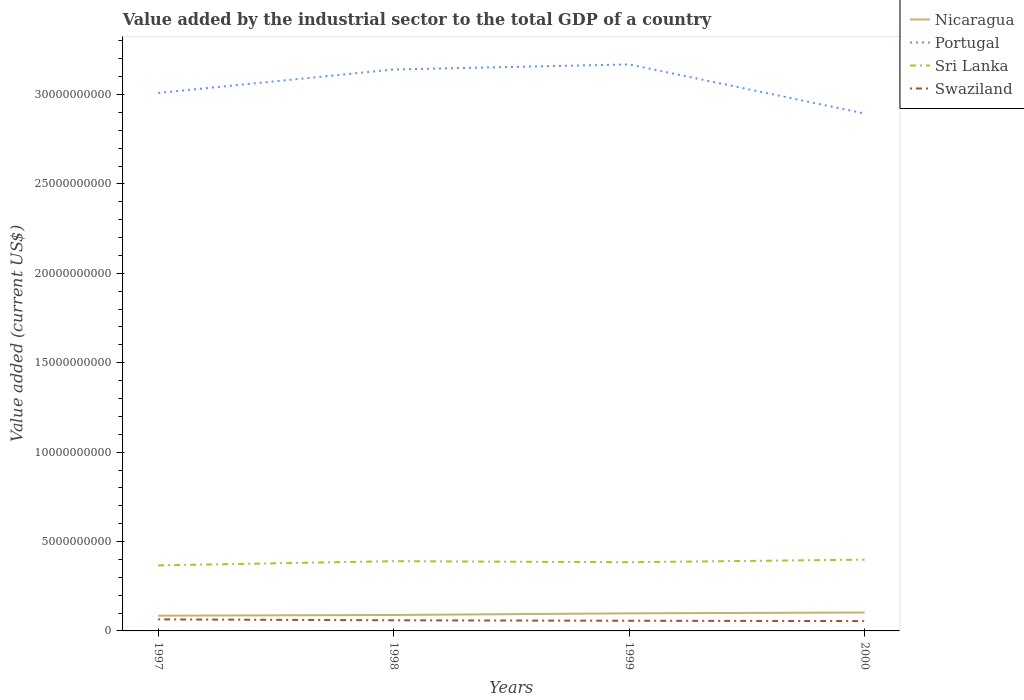How many different coloured lines are there?
Give a very brief answer. 4. Across all years, what is the maximum value added by the industrial sector to the total GDP in Nicaragua?
Offer a very short reply. 8.53e+08. In which year was the value added by the industrial sector to the total GDP in Swaziland maximum?
Keep it short and to the point. 2000. What is the total value added by the industrial sector to the total GDP in Portugal in the graph?
Offer a very short reply. -1.31e+09. What is the difference between the highest and the second highest value added by the industrial sector to the total GDP in Sri Lanka?
Offer a very short reply. 3.22e+08. What is the difference between the highest and the lowest value added by the industrial sector to the total GDP in Portugal?
Ensure brevity in your answer.  2. Does the graph contain grids?
Keep it short and to the point. No. Where does the legend appear in the graph?
Offer a very short reply. Top right. What is the title of the graph?
Keep it short and to the point. Value added by the industrial sector to the total GDP of a country. Does "Bhutan" appear as one of the legend labels in the graph?
Your response must be concise. No. What is the label or title of the Y-axis?
Offer a very short reply. Value added (current US$). What is the Value added (current US$) of Nicaragua in 1997?
Make the answer very short. 8.53e+08. What is the Value added (current US$) of Portugal in 1997?
Provide a succinct answer. 3.01e+1. What is the Value added (current US$) in Sri Lanka in 1997?
Offer a terse response. 3.66e+09. What is the Value added (current US$) of Swaziland in 1997?
Your response must be concise. 6.46e+08. What is the Value added (current US$) in Nicaragua in 1998?
Your response must be concise. 8.91e+08. What is the Value added (current US$) of Portugal in 1998?
Provide a succinct answer. 3.14e+1. What is the Value added (current US$) of Sri Lanka in 1998?
Your answer should be compact. 3.90e+09. What is the Value added (current US$) in Swaziland in 1998?
Offer a very short reply. 5.94e+08. What is the Value added (current US$) in Nicaragua in 1999?
Give a very brief answer. 9.84e+08. What is the Value added (current US$) of Portugal in 1999?
Your response must be concise. 3.17e+1. What is the Value added (current US$) in Sri Lanka in 1999?
Offer a terse response. 3.84e+09. What is the Value added (current US$) of Swaziland in 1999?
Provide a short and direct response. 5.69e+08. What is the Value added (current US$) of Nicaragua in 2000?
Offer a terse response. 1.03e+09. What is the Value added (current US$) of Portugal in 2000?
Offer a terse response. 2.89e+1. What is the Value added (current US$) of Sri Lanka in 2000?
Ensure brevity in your answer.  3.99e+09. What is the Value added (current US$) of Swaziland in 2000?
Offer a terse response. 5.50e+08. Across all years, what is the maximum Value added (current US$) in Nicaragua?
Make the answer very short. 1.03e+09. Across all years, what is the maximum Value added (current US$) in Portugal?
Give a very brief answer. 3.17e+1. Across all years, what is the maximum Value added (current US$) in Sri Lanka?
Offer a terse response. 3.99e+09. Across all years, what is the maximum Value added (current US$) in Swaziland?
Offer a terse response. 6.46e+08. Across all years, what is the minimum Value added (current US$) in Nicaragua?
Offer a very short reply. 8.53e+08. Across all years, what is the minimum Value added (current US$) of Portugal?
Your response must be concise. 2.89e+1. Across all years, what is the minimum Value added (current US$) in Sri Lanka?
Offer a terse response. 3.66e+09. Across all years, what is the minimum Value added (current US$) in Swaziland?
Offer a very short reply. 5.50e+08. What is the total Value added (current US$) of Nicaragua in the graph?
Offer a very short reply. 3.76e+09. What is the total Value added (current US$) of Portugal in the graph?
Provide a succinct answer. 1.22e+11. What is the total Value added (current US$) in Sri Lanka in the graph?
Your answer should be very brief. 1.54e+1. What is the total Value added (current US$) of Swaziland in the graph?
Give a very brief answer. 2.36e+09. What is the difference between the Value added (current US$) of Nicaragua in 1997 and that in 1998?
Offer a terse response. -3.82e+07. What is the difference between the Value added (current US$) in Portugal in 1997 and that in 1998?
Your response must be concise. -1.31e+09. What is the difference between the Value added (current US$) of Sri Lanka in 1997 and that in 1998?
Your answer should be very brief. -2.36e+08. What is the difference between the Value added (current US$) of Swaziland in 1997 and that in 1998?
Make the answer very short. 5.23e+07. What is the difference between the Value added (current US$) in Nicaragua in 1997 and that in 1999?
Your response must be concise. -1.31e+08. What is the difference between the Value added (current US$) of Portugal in 1997 and that in 1999?
Keep it short and to the point. -1.60e+09. What is the difference between the Value added (current US$) in Sri Lanka in 1997 and that in 1999?
Give a very brief answer. -1.77e+08. What is the difference between the Value added (current US$) in Swaziland in 1997 and that in 1999?
Offer a terse response. 7.76e+07. What is the difference between the Value added (current US$) of Nicaragua in 1997 and that in 2000?
Ensure brevity in your answer.  -1.76e+08. What is the difference between the Value added (current US$) of Portugal in 1997 and that in 2000?
Your answer should be very brief. 1.15e+09. What is the difference between the Value added (current US$) of Sri Lanka in 1997 and that in 2000?
Provide a succinct answer. -3.22e+08. What is the difference between the Value added (current US$) of Swaziland in 1997 and that in 2000?
Give a very brief answer. 9.65e+07. What is the difference between the Value added (current US$) in Nicaragua in 1998 and that in 1999?
Your response must be concise. -9.23e+07. What is the difference between the Value added (current US$) of Portugal in 1998 and that in 1999?
Offer a terse response. -2.85e+08. What is the difference between the Value added (current US$) in Sri Lanka in 1998 and that in 1999?
Make the answer very short. 5.89e+07. What is the difference between the Value added (current US$) in Swaziland in 1998 and that in 1999?
Your response must be concise. 2.54e+07. What is the difference between the Value added (current US$) of Nicaragua in 1998 and that in 2000?
Provide a succinct answer. -1.38e+08. What is the difference between the Value added (current US$) in Portugal in 1998 and that in 2000?
Offer a very short reply. 2.46e+09. What is the difference between the Value added (current US$) of Sri Lanka in 1998 and that in 2000?
Provide a short and direct response. -8.55e+07. What is the difference between the Value added (current US$) in Swaziland in 1998 and that in 2000?
Your answer should be compact. 4.42e+07. What is the difference between the Value added (current US$) in Nicaragua in 1999 and that in 2000?
Provide a short and direct response. -4.56e+07. What is the difference between the Value added (current US$) of Portugal in 1999 and that in 2000?
Give a very brief answer. 2.75e+09. What is the difference between the Value added (current US$) in Sri Lanka in 1999 and that in 2000?
Offer a terse response. -1.44e+08. What is the difference between the Value added (current US$) of Swaziland in 1999 and that in 2000?
Offer a terse response. 1.89e+07. What is the difference between the Value added (current US$) in Nicaragua in 1997 and the Value added (current US$) in Portugal in 1998?
Keep it short and to the point. -3.05e+1. What is the difference between the Value added (current US$) in Nicaragua in 1997 and the Value added (current US$) in Sri Lanka in 1998?
Your answer should be compact. -3.05e+09. What is the difference between the Value added (current US$) of Nicaragua in 1997 and the Value added (current US$) of Swaziland in 1998?
Offer a very short reply. 2.59e+08. What is the difference between the Value added (current US$) of Portugal in 1997 and the Value added (current US$) of Sri Lanka in 1998?
Keep it short and to the point. 2.62e+1. What is the difference between the Value added (current US$) of Portugal in 1997 and the Value added (current US$) of Swaziland in 1998?
Make the answer very short. 2.95e+1. What is the difference between the Value added (current US$) of Sri Lanka in 1997 and the Value added (current US$) of Swaziland in 1998?
Keep it short and to the point. 3.07e+09. What is the difference between the Value added (current US$) in Nicaragua in 1997 and the Value added (current US$) in Portugal in 1999?
Provide a succinct answer. -3.08e+1. What is the difference between the Value added (current US$) in Nicaragua in 1997 and the Value added (current US$) in Sri Lanka in 1999?
Offer a very short reply. -2.99e+09. What is the difference between the Value added (current US$) of Nicaragua in 1997 and the Value added (current US$) of Swaziland in 1999?
Ensure brevity in your answer.  2.85e+08. What is the difference between the Value added (current US$) in Portugal in 1997 and the Value added (current US$) in Sri Lanka in 1999?
Make the answer very short. 2.62e+1. What is the difference between the Value added (current US$) in Portugal in 1997 and the Value added (current US$) in Swaziland in 1999?
Offer a very short reply. 2.95e+1. What is the difference between the Value added (current US$) of Sri Lanka in 1997 and the Value added (current US$) of Swaziland in 1999?
Offer a terse response. 3.10e+09. What is the difference between the Value added (current US$) in Nicaragua in 1997 and the Value added (current US$) in Portugal in 2000?
Provide a short and direct response. -2.81e+1. What is the difference between the Value added (current US$) of Nicaragua in 1997 and the Value added (current US$) of Sri Lanka in 2000?
Your response must be concise. -3.13e+09. What is the difference between the Value added (current US$) in Nicaragua in 1997 and the Value added (current US$) in Swaziland in 2000?
Provide a short and direct response. 3.03e+08. What is the difference between the Value added (current US$) of Portugal in 1997 and the Value added (current US$) of Sri Lanka in 2000?
Offer a terse response. 2.61e+1. What is the difference between the Value added (current US$) of Portugal in 1997 and the Value added (current US$) of Swaziland in 2000?
Offer a very short reply. 2.95e+1. What is the difference between the Value added (current US$) of Sri Lanka in 1997 and the Value added (current US$) of Swaziland in 2000?
Make the answer very short. 3.11e+09. What is the difference between the Value added (current US$) in Nicaragua in 1998 and the Value added (current US$) in Portugal in 1999?
Ensure brevity in your answer.  -3.08e+1. What is the difference between the Value added (current US$) in Nicaragua in 1998 and the Value added (current US$) in Sri Lanka in 1999?
Give a very brief answer. -2.95e+09. What is the difference between the Value added (current US$) in Nicaragua in 1998 and the Value added (current US$) in Swaziland in 1999?
Give a very brief answer. 3.23e+08. What is the difference between the Value added (current US$) of Portugal in 1998 and the Value added (current US$) of Sri Lanka in 1999?
Give a very brief answer. 2.76e+1. What is the difference between the Value added (current US$) in Portugal in 1998 and the Value added (current US$) in Swaziland in 1999?
Offer a very short reply. 3.08e+1. What is the difference between the Value added (current US$) in Sri Lanka in 1998 and the Value added (current US$) in Swaziland in 1999?
Make the answer very short. 3.33e+09. What is the difference between the Value added (current US$) in Nicaragua in 1998 and the Value added (current US$) in Portugal in 2000?
Provide a succinct answer. -2.80e+1. What is the difference between the Value added (current US$) of Nicaragua in 1998 and the Value added (current US$) of Sri Lanka in 2000?
Provide a succinct answer. -3.09e+09. What is the difference between the Value added (current US$) of Nicaragua in 1998 and the Value added (current US$) of Swaziland in 2000?
Provide a short and direct response. 3.42e+08. What is the difference between the Value added (current US$) of Portugal in 1998 and the Value added (current US$) of Sri Lanka in 2000?
Provide a succinct answer. 2.74e+1. What is the difference between the Value added (current US$) of Portugal in 1998 and the Value added (current US$) of Swaziland in 2000?
Make the answer very short. 3.09e+1. What is the difference between the Value added (current US$) in Sri Lanka in 1998 and the Value added (current US$) in Swaziland in 2000?
Ensure brevity in your answer.  3.35e+09. What is the difference between the Value added (current US$) in Nicaragua in 1999 and the Value added (current US$) in Portugal in 2000?
Offer a terse response. -2.80e+1. What is the difference between the Value added (current US$) of Nicaragua in 1999 and the Value added (current US$) of Sri Lanka in 2000?
Offer a very short reply. -3.00e+09. What is the difference between the Value added (current US$) in Nicaragua in 1999 and the Value added (current US$) in Swaziland in 2000?
Provide a short and direct response. 4.34e+08. What is the difference between the Value added (current US$) in Portugal in 1999 and the Value added (current US$) in Sri Lanka in 2000?
Provide a short and direct response. 2.77e+1. What is the difference between the Value added (current US$) in Portugal in 1999 and the Value added (current US$) in Swaziland in 2000?
Offer a terse response. 3.11e+1. What is the difference between the Value added (current US$) in Sri Lanka in 1999 and the Value added (current US$) in Swaziland in 2000?
Make the answer very short. 3.29e+09. What is the average Value added (current US$) of Nicaragua per year?
Provide a short and direct response. 9.39e+08. What is the average Value added (current US$) of Portugal per year?
Offer a terse response. 3.05e+1. What is the average Value added (current US$) in Sri Lanka per year?
Ensure brevity in your answer.  3.85e+09. What is the average Value added (current US$) of Swaziland per year?
Your answer should be compact. 5.90e+08. In the year 1997, what is the difference between the Value added (current US$) of Nicaragua and Value added (current US$) of Portugal?
Your response must be concise. -2.92e+1. In the year 1997, what is the difference between the Value added (current US$) in Nicaragua and Value added (current US$) in Sri Lanka?
Your response must be concise. -2.81e+09. In the year 1997, what is the difference between the Value added (current US$) of Nicaragua and Value added (current US$) of Swaziland?
Keep it short and to the point. 2.07e+08. In the year 1997, what is the difference between the Value added (current US$) of Portugal and Value added (current US$) of Sri Lanka?
Give a very brief answer. 2.64e+1. In the year 1997, what is the difference between the Value added (current US$) of Portugal and Value added (current US$) of Swaziland?
Your response must be concise. 2.94e+1. In the year 1997, what is the difference between the Value added (current US$) in Sri Lanka and Value added (current US$) in Swaziland?
Your answer should be very brief. 3.02e+09. In the year 1998, what is the difference between the Value added (current US$) of Nicaragua and Value added (current US$) of Portugal?
Provide a short and direct response. -3.05e+1. In the year 1998, what is the difference between the Value added (current US$) in Nicaragua and Value added (current US$) in Sri Lanka?
Your answer should be compact. -3.01e+09. In the year 1998, what is the difference between the Value added (current US$) in Nicaragua and Value added (current US$) in Swaziland?
Your answer should be very brief. 2.97e+08. In the year 1998, what is the difference between the Value added (current US$) of Portugal and Value added (current US$) of Sri Lanka?
Make the answer very short. 2.75e+1. In the year 1998, what is the difference between the Value added (current US$) in Portugal and Value added (current US$) in Swaziland?
Provide a short and direct response. 3.08e+1. In the year 1998, what is the difference between the Value added (current US$) in Sri Lanka and Value added (current US$) in Swaziland?
Your answer should be very brief. 3.31e+09. In the year 1999, what is the difference between the Value added (current US$) in Nicaragua and Value added (current US$) in Portugal?
Provide a short and direct response. -3.07e+1. In the year 1999, what is the difference between the Value added (current US$) in Nicaragua and Value added (current US$) in Sri Lanka?
Provide a short and direct response. -2.86e+09. In the year 1999, what is the difference between the Value added (current US$) of Nicaragua and Value added (current US$) of Swaziland?
Your answer should be very brief. 4.15e+08. In the year 1999, what is the difference between the Value added (current US$) in Portugal and Value added (current US$) in Sri Lanka?
Offer a very short reply. 2.78e+1. In the year 1999, what is the difference between the Value added (current US$) of Portugal and Value added (current US$) of Swaziland?
Your answer should be compact. 3.11e+1. In the year 1999, what is the difference between the Value added (current US$) of Sri Lanka and Value added (current US$) of Swaziland?
Keep it short and to the point. 3.27e+09. In the year 2000, what is the difference between the Value added (current US$) of Nicaragua and Value added (current US$) of Portugal?
Provide a short and direct response. -2.79e+1. In the year 2000, what is the difference between the Value added (current US$) in Nicaragua and Value added (current US$) in Sri Lanka?
Your answer should be very brief. -2.96e+09. In the year 2000, what is the difference between the Value added (current US$) in Nicaragua and Value added (current US$) in Swaziland?
Offer a very short reply. 4.80e+08. In the year 2000, what is the difference between the Value added (current US$) of Portugal and Value added (current US$) of Sri Lanka?
Your answer should be very brief. 2.50e+1. In the year 2000, what is the difference between the Value added (current US$) in Portugal and Value added (current US$) in Swaziland?
Offer a very short reply. 2.84e+1. In the year 2000, what is the difference between the Value added (current US$) in Sri Lanka and Value added (current US$) in Swaziland?
Your answer should be very brief. 3.44e+09. What is the ratio of the Value added (current US$) of Nicaragua in 1997 to that in 1998?
Give a very brief answer. 0.96. What is the ratio of the Value added (current US$) of Portugal in 1997 to that in 1998?
Ensure brevity in your answer.  0.96. What is the ratio of the Value added (current US$) of Sri Lanka in 1997 to that in 1998?
Your answer should be very brief. 0.94. What is the ratio of the Value added (current US$) in Swaziland in 1997 to that in 1998?
Offer a terse response. 1.09. What is the ratio of the Value added (current US$) in Nicaragua in 1997 to that in 1999?
Ensure brevity in your answer.  0.87. What is the ratio of the Value added (current US$) of Portugal in 1997 to that in 1999?
Your answer should be very brief. 0.95. What is the ratio of the Value added (current US$) in Sri Lanka in 1997 to that in 1999?
Provide a succinct answer. 0.95. What is the ratio of the Value added (current US$) of Swaziland in 1997 to that in 1999?
Ensure brevity in your answer.  1.14. What is the ratio of the Value added (current US$) of Nicaragua in 1997 to that in 2000?
Make the answer very short. 0.83. What is the ratio of the Value added (current US$) of Portugal in 1997 to that in 2000?
Give a very brief answer. 1.04. What is the ratio of the Value added (current US$) of Sri Lanka in 1997 to that in 2000?
Your answer should be very brief. 0.92. What is the ratio of the Value added (current US$) of Swaziland in 1997 to that in 2000?
Your response must be concise. 1.18. What is the ratio of the Value added (current US$) in Nicaragua in 1998 to that in 1999?
Give a very brief answer. 0.91. What is the ratio of the Value added (current US$) of Portugal in 1998 to that in 1999?
Offer a terse response. 0.99. What is the ratio of the Value added (current US$) in Sri Lanka in 1998 to that in 1999?
Your answer should be very brief. 1.02. What is the ratio of the Value added (current US$) in Swaziland in 1998 to that in 1999?
Give a very brief answer. 1.04. What is the ratio of the Value added (current US$) of Nicaragua in 1998 to that in 2000?
Offer a very short reply. 0.87. What is the ratio of the Value added (current US$) in Portugal in 1998 to that in 2000?
Your response must be concise. 1.09. What is the ratio of the Value added (current US$) in Sri Lanka in 1998 to that in 2000?
Ensure brevity in your answer.  0.98. What is the ratio of the Value added (current US$) in Swaziland in 1998 to that in 2000?
Offer a terse response. 1.08. What is the ratio of the Value added (current US$) in Nicaragua in 1999 to that in 2000?
Provide a succinct answer. 0.96. What is the ratio of the Value added (current US$) of Portugal in 1999 to that in 2000?
Offer a terse response. 1.09. What is the ratio of the Value added (current US$) of Sri Lanka in 1999 to that in 2000?
Your response must be concise. 0.96. What is the ratio of the Value added (current US$) of Swaziland in 1999 to that in 2000?
Ensure brevity in your answer.  1.03. What is the difference between the highest and the second highest Value added (current US$) of Nicaragua?
Your answer should be very brief. 4.56e+07. What is the difference between the highest and the second highest Value added (current US$) in Portugal?
Make the answer very short. 2.85e+08. What is the difference between the highest and the second highest Value added (current US$) of Sri Lanka?
Give a very brief answer. 8.55e+07. What is the difference between the highest and the second highest Value added (current US$) in Swaziland?
Keep it short and to the point. 5.23e+07. What is the difference between the highest and the lowest Value added (current US$) in Nicaragua?
Make the answer very short. 1.76e+08. What is the difference between the highest and the lowest Value added (current US$) of Portugal?
Provide a succinct answer. 2.75e+09. What is the difference between the highest and the lowest Value added (current US$) in Sri Lanka?
Your response must be concise. 3.22e+08. What is the difference between the highest and the lowest Value added (current US$) in Swaziland?
Make the answer very short. 9.65e+07. 